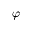Convert formula to latex. <formula><loc_0><loc_0><loc_500><loc_500>\varphi</formula> 